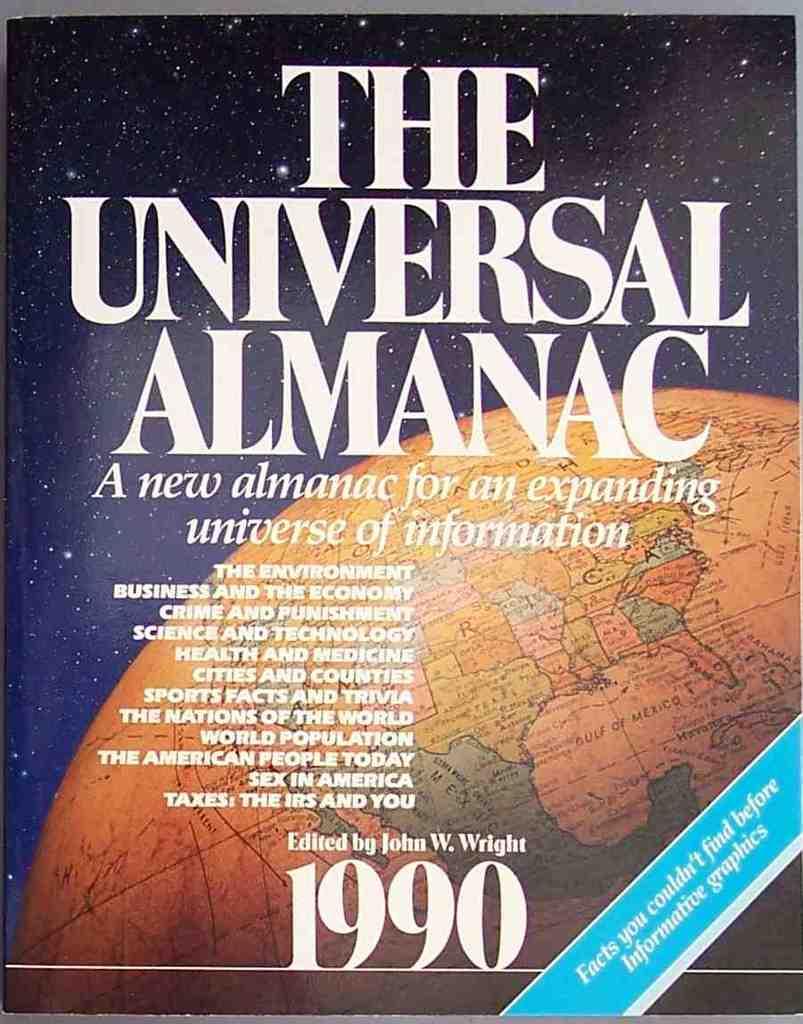What is the name of the almanac?
Provide a succinct answer. The universal almanac. 